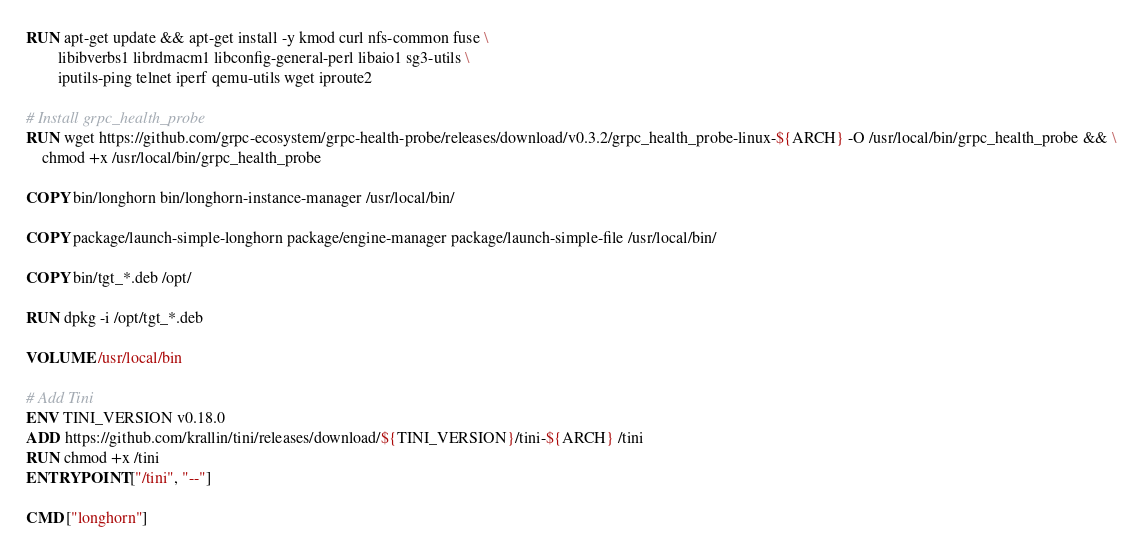Convert code to text. <code><loc_0><loc_0><loc_500><loc_500><_Dockerfile_>
RUN apt-get update && apt-get install -y kmod curl nfs-common fuse \
        libibverbs1 librdmacm1 libconfig-general-perl libaio1 sg3-utils \
        iputils-ping telnet iperf qemu-utils wget iproute2

# Install grpc_health_probe
RUN wget https://github.com/grpc-ecosystem/grpc-health-probe/releases/download/v0.3.2/grpc_health_probe-linux-${ARCH} -O /usr/local/bin/grpc_health_probe && \
    chmod +x /usr/local/bin/grpc_health_probe

COPY bin/longhorn bin/longhorn-instance-manager /usr/local/bin/

COPY package/launch-simple-longhorn package/engine-manager package/launch-simple-file /usr/local/bin/

COPY bin/tgt_*.deb /opt/

RUN dpkg -i /opt/tgt_*.deb

VOLUME /usr/local/bin

# Add Tini
ENV TINI_VERSION v0.18.0
ADD https://github.com/krallin/tini/releases/download/${TINI_VERSION}/tini-${ARCH} /tini
RUN chmod +x /tini
ENTRYPOINT ["/tini", "--"]

CMD ["longhorn"]
</code> 